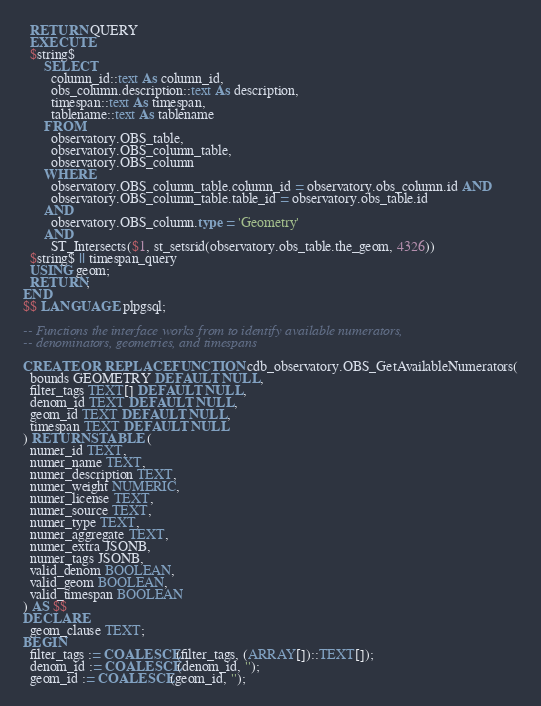Convert code to text. <code><loc_0><loc_0><loc_500><loc_500><_SQL_>  RETURN QUERY
  EXECUTE
  $string$
      SELECT
        column_id::text As column_id,
        obs_column.description::text As description,
        timespan::text As timespan,
        tablename::text As tablename
      FROM
        observatory.OBS_table,
        observatory.OBS_column_table,
        observatory.OBS_column
      WHERE
        observatory.OBS_column_table.column_id = observatory.obs_column.id AND
        observatory.OBS_column_table.table_id = observatory.obs_table.id
      AND
        observatory.OBS_column.type = 'Geometry'
      AND
        ST_Intersects($1, st_setsrid(observatory.obs_table.the_geom, 4326))
  $string$ || timespan_query
  USING geom;
  RETURN;
END
$$ LANGUAGE plpgsql;

-- Functions the interface works from to identify available numerators,
-- denominators, geometries, and timespans

CREATE OR REPLACE FUNCTION cdb_observatory.OBS_GetAvailableNumerators(
  bounds GEOMETRY DEFAULT NULL,
  filter_tags TEXT[] DEFAULT NULL,
  denom_id TEXT DEFAULT NULL,
  geom_id TEXT DEFAULT NULL,
  timespan TEXT DEFAULT NULL
) RETURNS TABLE (
  numer_id TEXT,
  numer_name TEXT,
  numer_description TEXT,
  numer_weight NUMERIC,
  numer_license TEXT,
  numer_source TEXT,
  numer_type TEXT,
  numer_aggregate TEXT,
  numer_extra JSONB,
  numer_tags JSONB,
  valid_denom BOOLEAN,
  valid_geom BOOLEAN,
  valid_timespan BOOLEAN
) AS $$
DECLARE
  geom_clause TEXT;
BEGIN
  filter_tags := COALESCE(filter_tags, (ARRAY[])::TEXT[]);
  denom_id := COALESCE(denom_id, '');
  geom_id := COALESCE(geom_id, '');</code> 